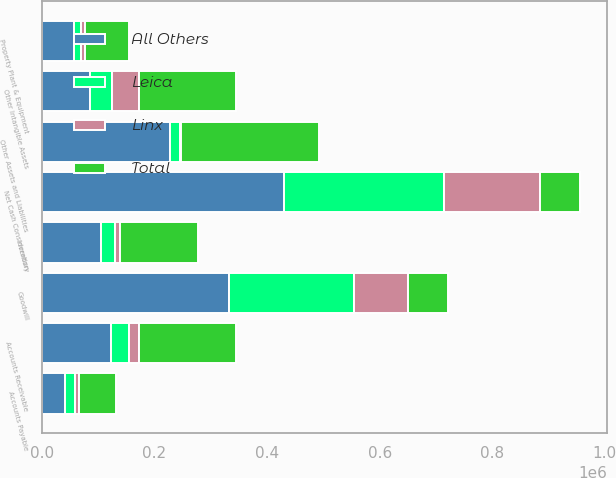Convert chart to OTSL. <chart><loc_0><loc_0><loc_500><loc_500><stacked_bar_chart><ecel><fcel>Accounts Receivable<fcel>Inventory<fcel>Property Plant & Equipment<fcel>Goodwill<fcel>Other Intangible Assets<fcel>Accounts Payable<fcel>Other Assets and Liabilities<fcel>Net Cash Consideration<nl><fcel>All Others<fcel>123064<fcel>105454<fcel>56239<fcel>331806<fcel>85592<fcel>40358<fcel>226912<fcel>429382<nl><fcel>Linx<fcel>17094<fcel>8437<fcel>8498<fcel>96480<fcel>47188<fcel>7430<fcel>600<fcel>170867<nl><fcel>Leica<fcel>31820<fcel>24735<fcel>12351<fcel>221975<fcel>39582<fcel>17918<fcel>18850<fcel>284834<nl><fcel>Total<fcel>171978<fcel>138626<fcel>77088<fcel>71397<fcel>172362<fcel>65706<fcel>245162<fcel>71397<nl></chart> 